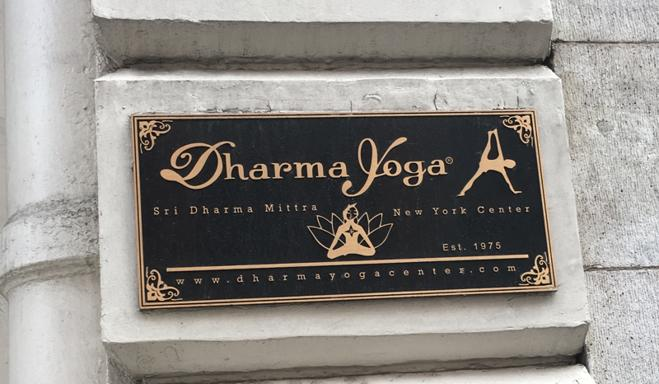Describe the design on the sign. The sign features an elegant design with gold text on a black background, enhancing the contrast and visibility. It includes detailed decorative elements such as ornate swirls around the border and a stylized lotus position figure within the logo. This design effectively captures attention and reflects the peaceful yet classic vibe of a yoga center. 